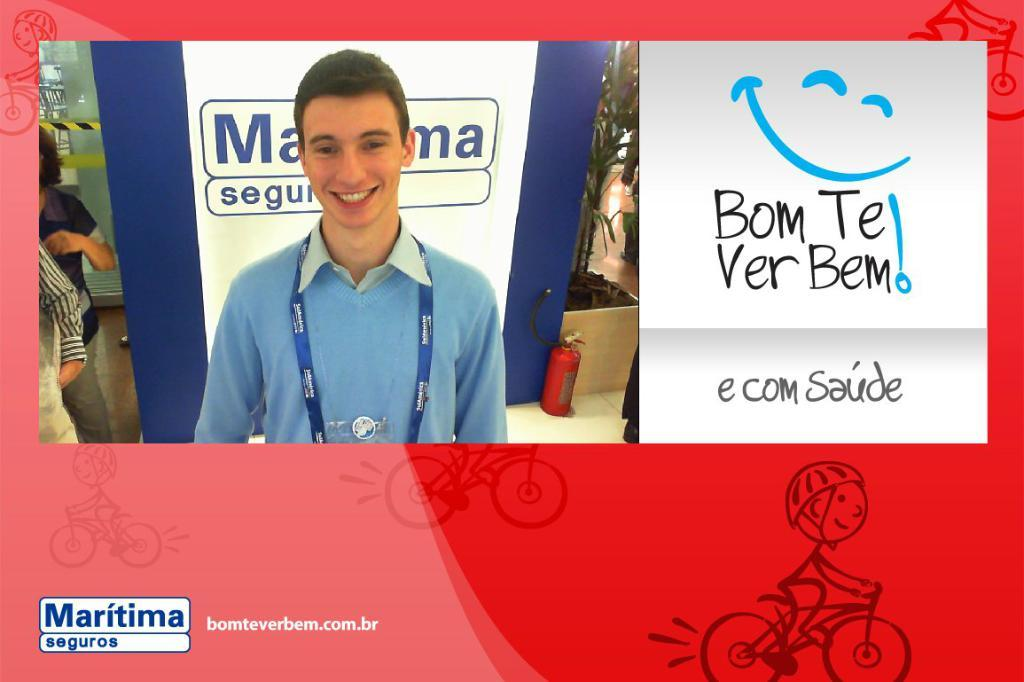<image>
Summarize the visual content of the image. Maritima Seguros reads the caption of this photo advert. 